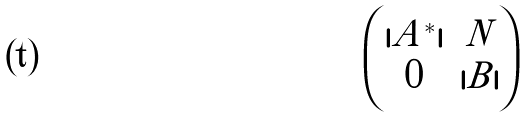Convert formula to latex. <formula><loc_0><loc_0><loc_500><loc_500>\begin{pmatrix} | A ^ { * } | & N \\ 0 & | B | \end{pmatrix}</formula> 